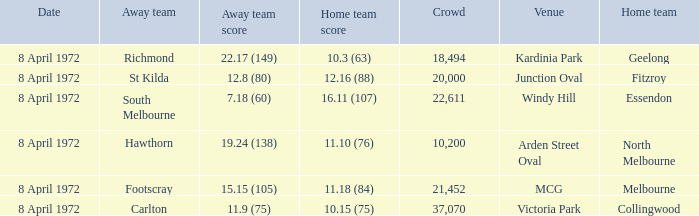Which Home team score has a Home team of geelong? 10.3 (63). 